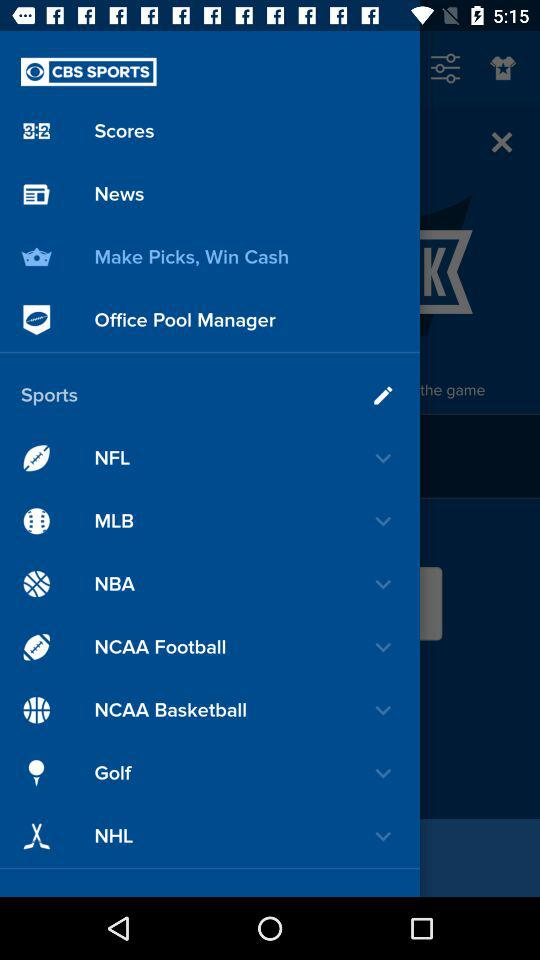What is the application name? The application name is "CBS SPORTS". 